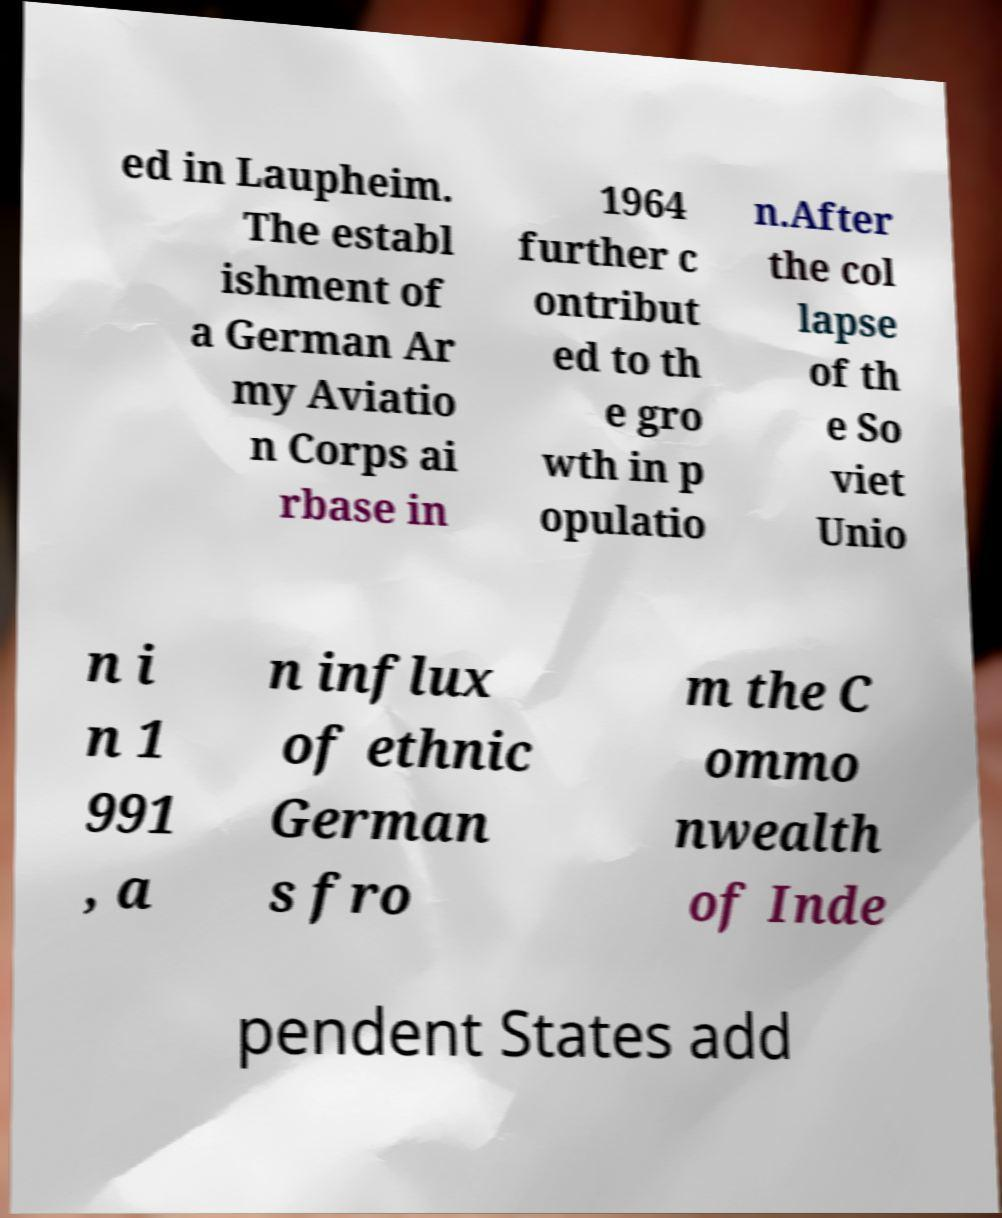I need the written content from this picture converted into text. Can you do that? ed in Laupheim. The establ ishment of a German Ar my Aviatio n Corps ai rbase in 1964 further c ontribut ed to th e gro wth in p opulatio n.After the col lapse of th e So viet Unio n i n 1 991 , a n influx of ethnic German s fro m the C ommo nwealth of Inde pendent States add 